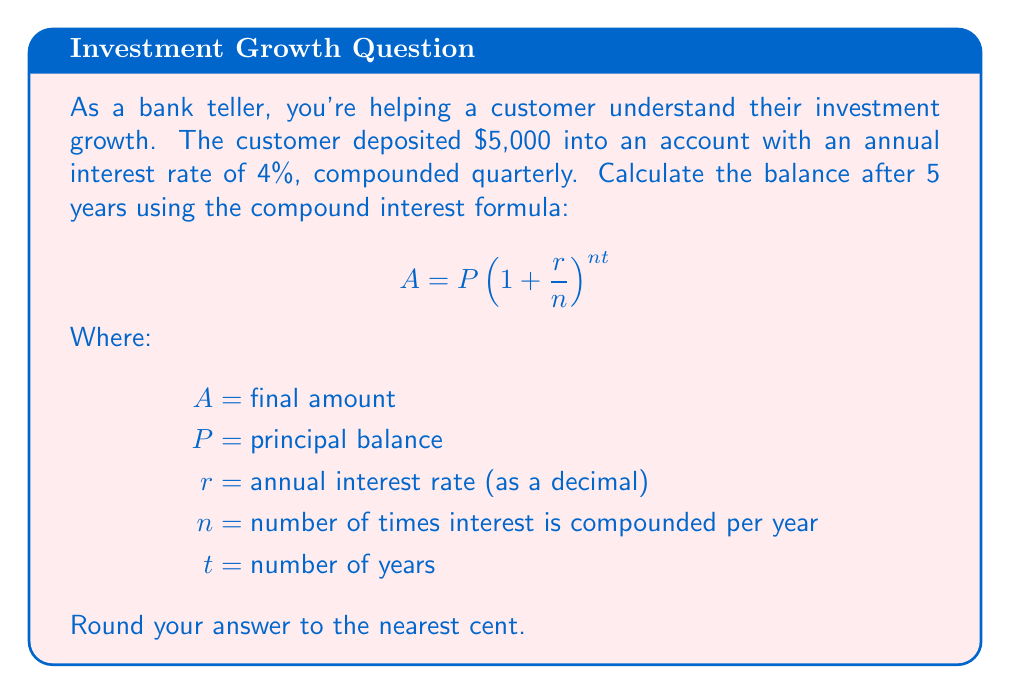Give your solution to this math problem. Let's break this down step-by-step:

1) First, let's identify our variables:
   $P = 5000$ (initial deposit)
   $r = 0.04$ (4% annual interest rate as a decimal)
   $n = 4$ (compounded quarterly, so 4 times per year)
   $t = 5$ (5 years)

2) Now, let's plug these values into our formula:

   $$ A = 5000(1 + \frac{0.04}{4})^{4 \cdot 5} $$

3) Simplify inside the parentheses:

   $$ A = 5000(1 + 0.01)^{20} $$

4) Calculate the exponent:

   $$ A = 5000(1.01)^{20} $$

5) Use a calculator to compute $(1.01)^{20}$:

   $$ A = 5000 \cdot 1.2201917030 $$

6) Multiply:

   $$ A = 6100.9585150 $$

7) Round to the nearest cent:

   $$ A = 6100.96 $$
Answer: $6100.96 